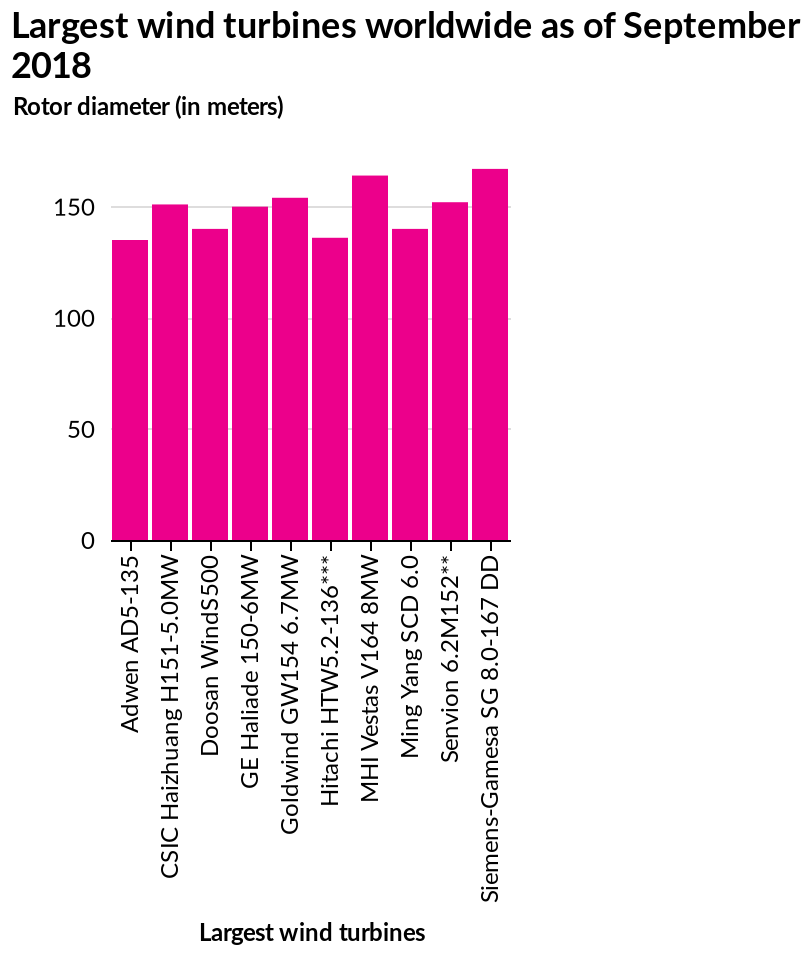<image>
What is the maximum value on the y-axis? The maximum value on the y-axis is 150, which represents the maximum rotor diameter of the wind turbines in meters. 